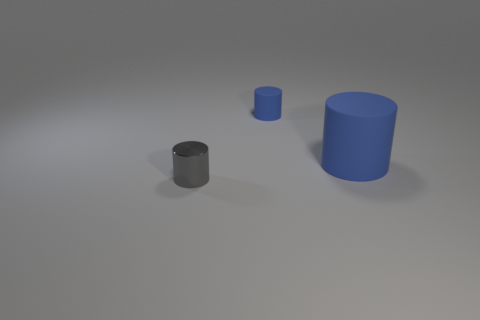Add 1 tiny things. How many objects exist? 4 Add 2 gray metallic cylinders. How many gray metallic cylinders exist? 3 Subtract 0 green spheres. How many objects are left? 3 Subtract all large things. Subtract all large cylinders. How many objects are left? 1 Add 3 matte objects. How many matte objects are left? 5 